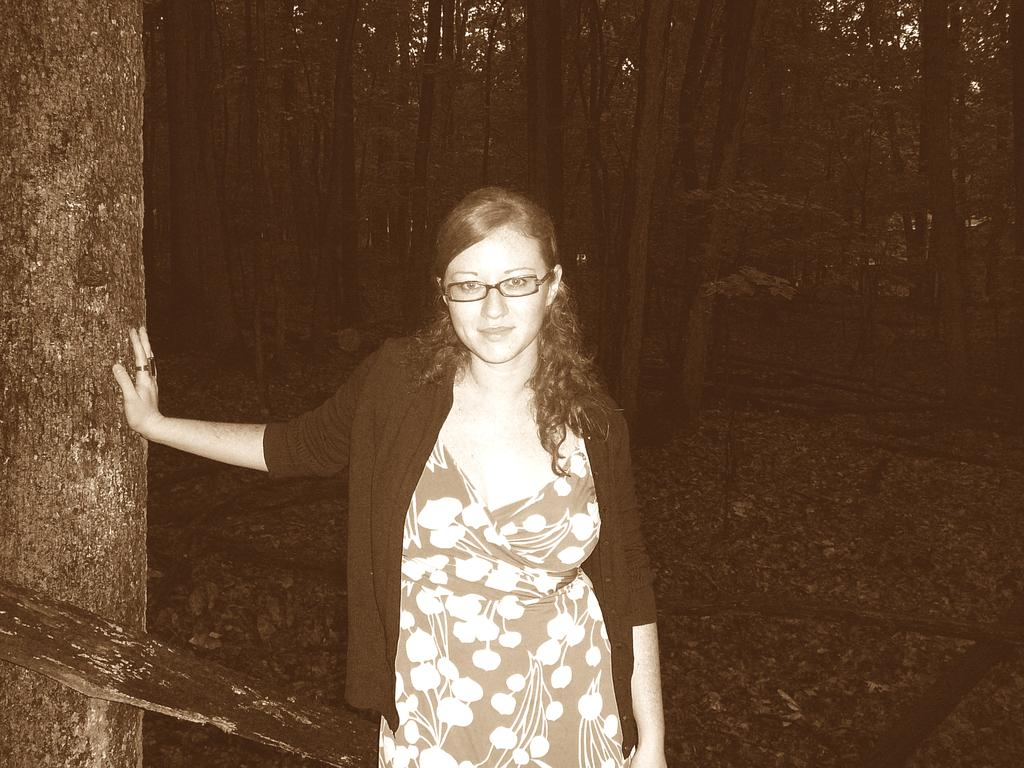What is the main subject of the image? The main subject of the image is a woman. What is the woman doing in the image? The woman is standing in the image. What accessory is the woman wearing? The woman is wearing spectacles in the image. What can be seen in the background of the image? There are trees in the background of the image. What is the color scheme of the image? The image is black and white in color. What type of gold material is used to create the canvas in the image? There is no canvas or gold material present in the image; it features a woman standing in a black and white setting. 